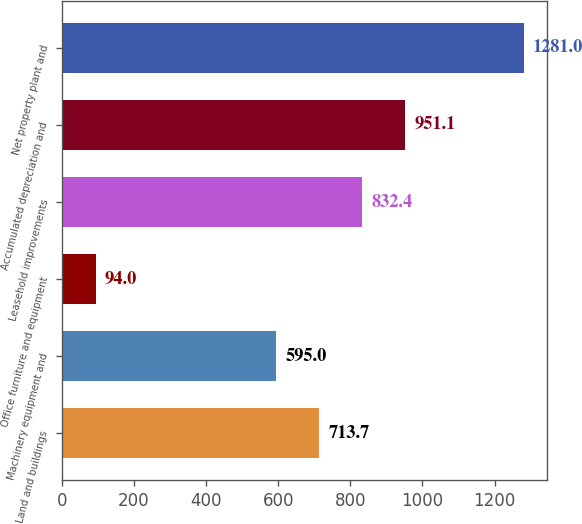<chart> <loc_0><loc_0><loc_500><loc_500><bar_chart><fcel>Land and buildings<fcel>Machinery equipment and<fcel>Office furniture and equipment<fcel>Leasehold improvements<fcel>Accumulated depreciation and<fcel>Net property plant and<nl><fcel>713.7<fcel>595<fcel>94<fcel>832.4<fcel>951.1<fcel>1281<nl></chart> 